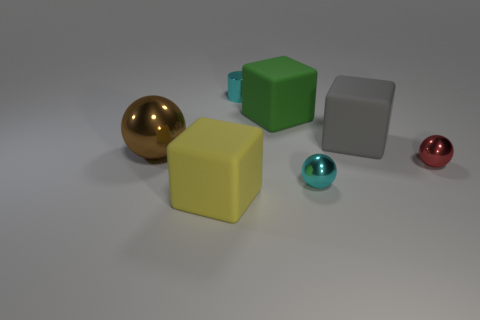Add 3 gray objects. How many objects exist? 10 Subtract all cubes. How many objects are left? 4 Subtract 1 red balls. How many objects are left? 6 Subtract all brown metal balls. Subtract all tiny red metal spheres. How many objects are left? 5 Add 7 tiny cyan cylinders. How many tiny cyan cylinders are left? 8 Add 3 cyan balls. How many cyan balls exist? 4 